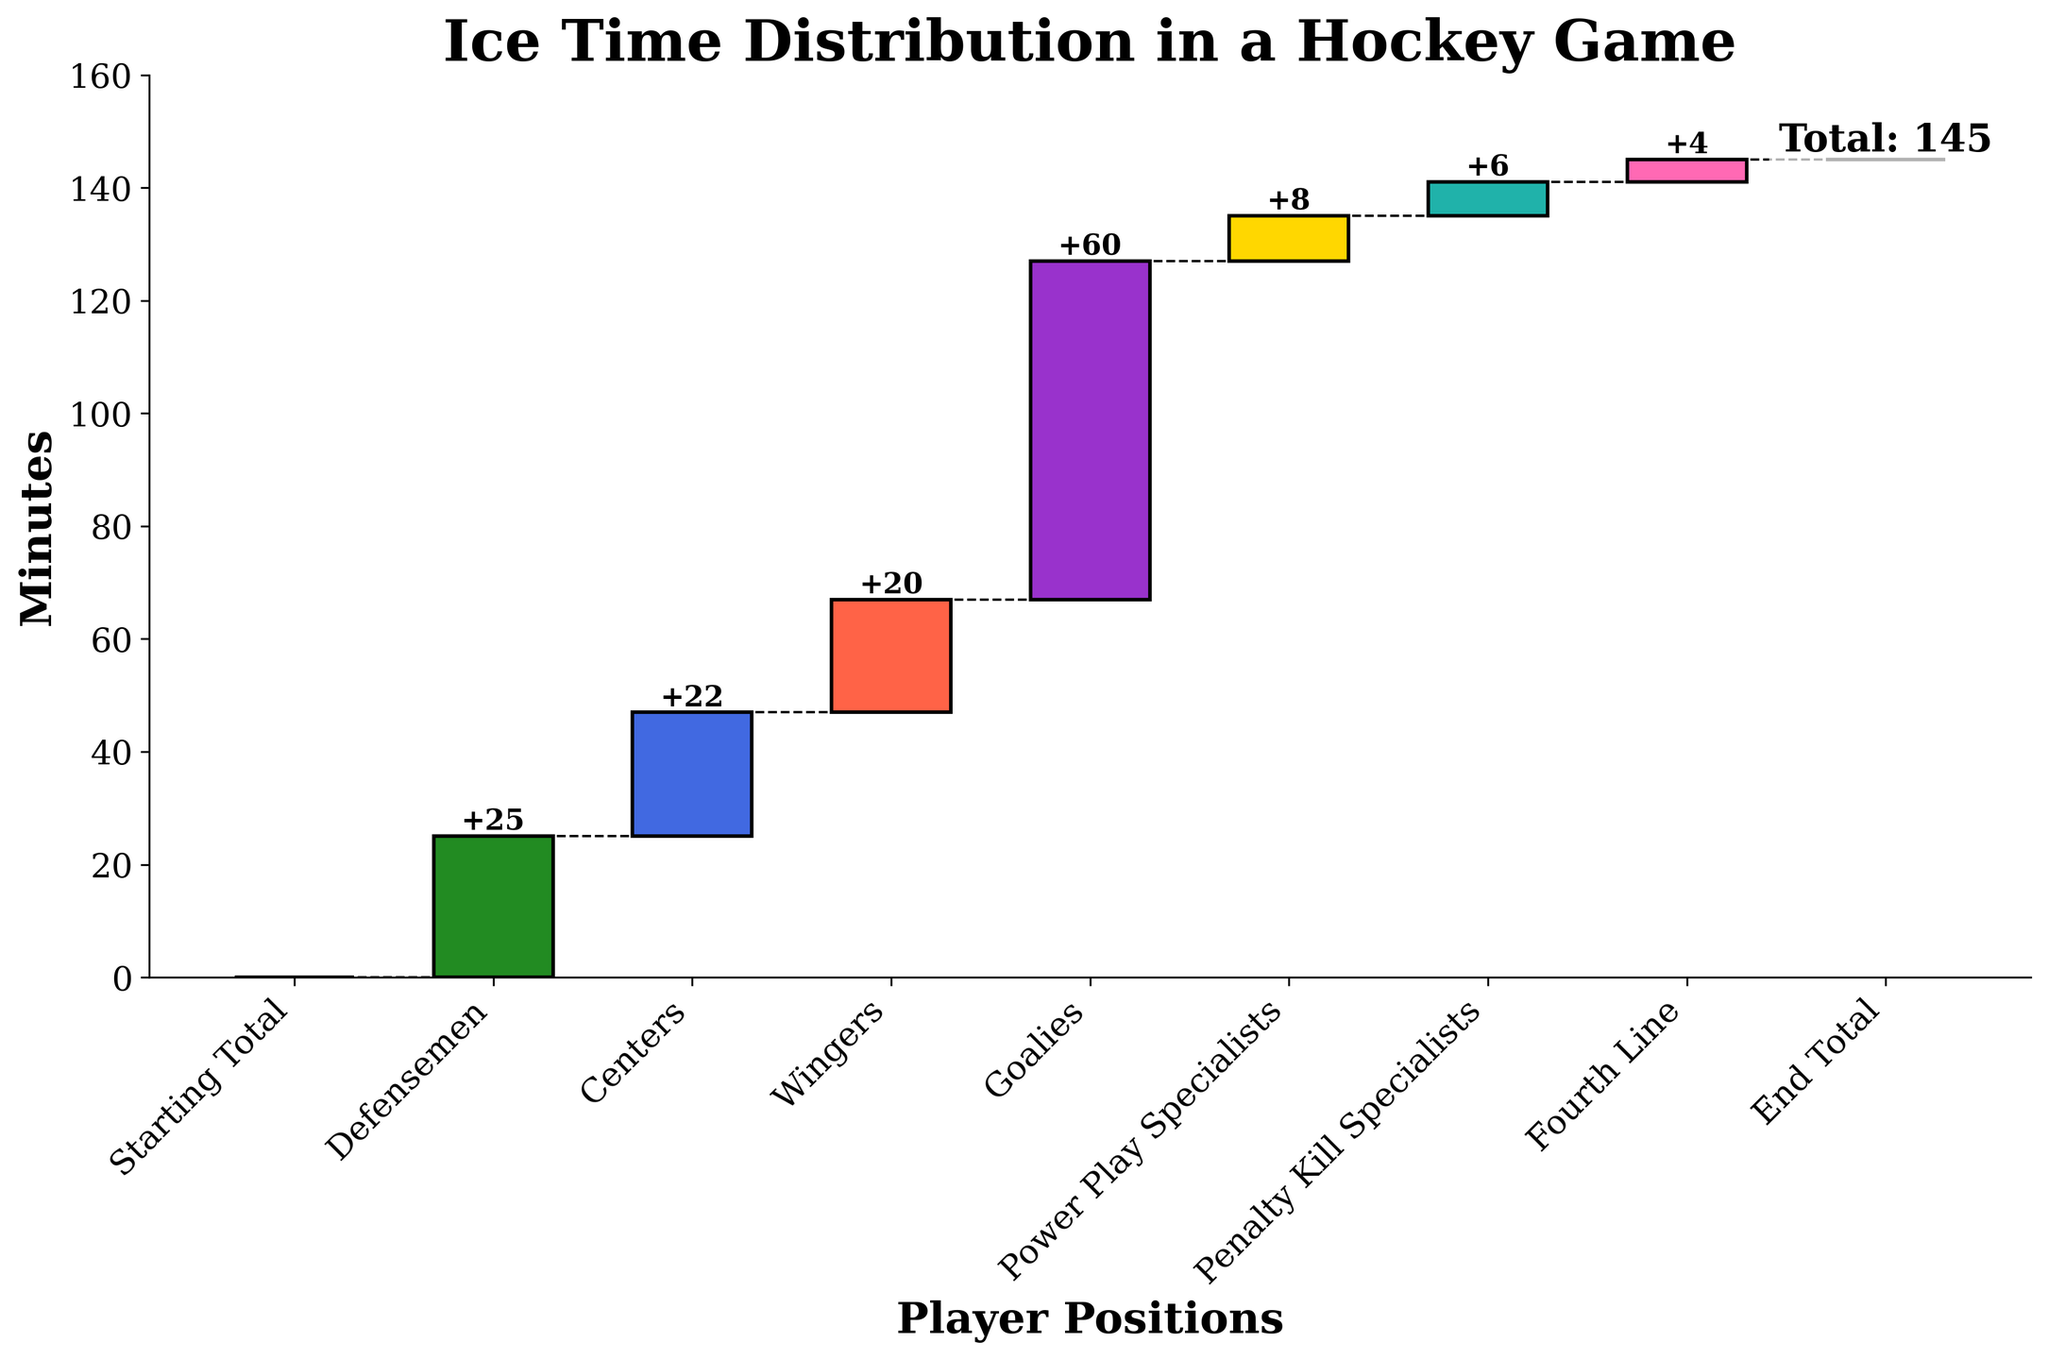What's the title of the figure? The title is located at the top of the chart and it clearly states what the figure is about. It reads "Ice Time Distribution in a Hockey Game".
Answer: Ice Time Distribution in a Hockey Game Which position accumulates the most minutes? By observing the height of each bar from zero, the Goalie has the highest bar, indicating the most minutes.
Answer: Goalies What is the running total ice time after Centers are included? Starting from zero, add the minutes for Defensemen (25) and Centers (22) which equals 47 as shown by the running total for Centers.
Answer: 47 How many minutes are played by Power Play Specialists compared to Penalty Kill Specialists? By looking at the lengths of the respective bars, Power Play Specialists play 8 minutes while Penalty Kill Specialists play 6 minutes. Comparing these values: 8 - 6 = 2.
Answer: 2 How many more minutes do Wingers play than the Fourth Line? The Wingers play 20 minutes while the Fourth Line plays 4 minutes. Subtract the Fourth Line minutes from the Wingers' minutes: 20 - 4 = 16.
Answer: 16 Which position has the least ice time and how much? The Fourth Line has the shortest bar, indicating the least ice time at 4 minutes.
Answer: Fourth Line, 4 minutes What is the total ice time represented in the chart? The End Total running total indicates the total ice time, which is 145 minutes.
Answer: 145 Does the ice time for Centers exceed the time for Power Play Specialists and Penalty Kill Specialists combined? Centers have 22 minutes, while adding Power Play Specialists' 8 minutes and Penalty Kill Specialists' 6 minutes results in 14 minutes. Since 22 is greater than 14, Centers exceed the combined time.
Answer: Yes What is the cumulative ice time after counting the Power Play Specialists? The running total for Power Play Specialists is 135 minutes as indicated on the chart.
Answer: 135 How is the gap represented between player positions? The gaps are represented by dashed connecting lines between the tops of each bar, indicating the running totals remain the same value across these lines.
Answer: Dashed lines 